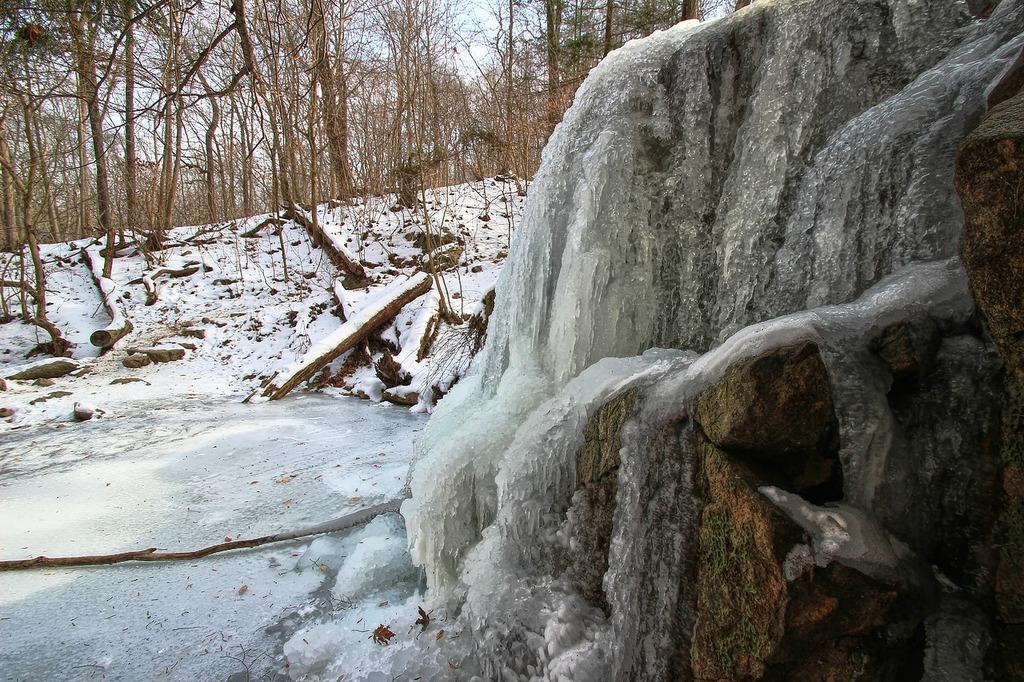Could you give a brief overview of what you see in this image? In this picture I can see trees and wooden objects on the ground. On the right side I can see rocks and snow. In the background I can see the sky. 